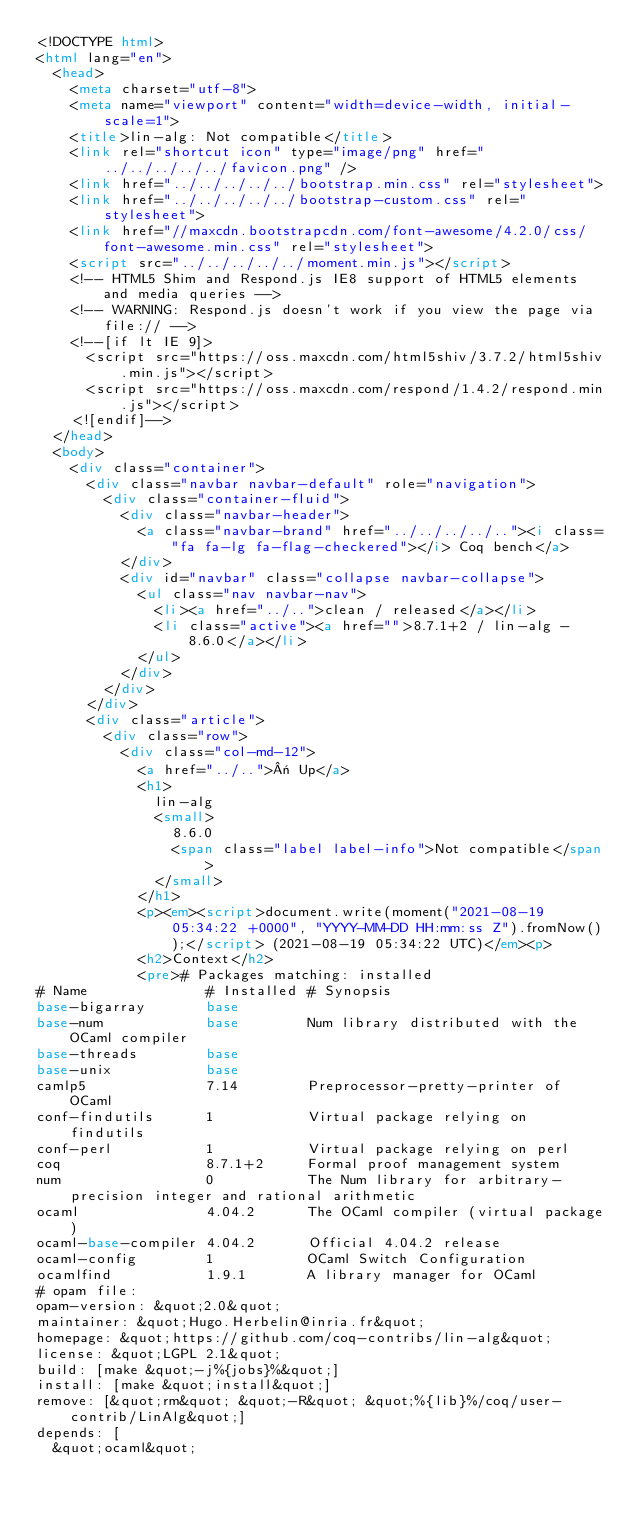Convert code to text. <code><loc_0><loc_0><loc_500><loc_500><_HTML_><!DOCTYPE html>
<html lang="en">
  <head>
    <meta charset="utf-8">
    <meta name="viewport" content="width=device-width, initial-scale=1">
    <title>lin-alg: Not compatible</title>
    <link rel="shortcut icon" type="image/png" href="../../../../../favicon.png" />
    <link href="../../../../../bootstrap.min.css" rel="stylesheet">
    <link href="../../../../../bootstrap-custom.css" rel="stylesheet">
    <link href="//maxcdn.bootstrapcdn.com/font-awesome/4.2.0/css/font-awesome.min.css" rel="stylesheet">
    <script src="../../../../../moment.min.js"></script>
    <!-- HTML5 Shim and Respond.js IE8 support of HTML5 elements and media queries -->
    <!-- WARNING: Respond.js doesn't work if you view the page via file:// -->
    <!--[if lt IE 9]>
      <script src="https://oss.maxcdn.com/html5shiv/3.7.2/html5shiv.min.js"></script>
      <script src="https://oss.maxcdn.com/respond/1.4.2/respond.min.js"></script>
    <![endif]-->
  </head>
  <body>
    <div class="container">
      <div class="navbar navbar-default" role="navigation">
        <div class="container-fluid">
          <div class="navbar-header">
            <a class="navbar-brand" href="../../../../.."><i class="fa fa-lg fa-flag-checkered"></i> Coq bench</a>
          </div>
          <div id="navbar" class="collapse navbar-collapse">
            <ul class="nav navbar-nav">
              <li><a href="../..">clean / released</a></li>
              <li class="active"><a href="">8.7.1+2 / lin-alg - 8.6.0</a></li>
            </ul>
          </div>
        </div>
      </div>
      <div class="article">
        <div class="row">
          <div class="col-md-12">
            <a href="../..">« Up</a>
            <h1>
              lin-alg
              <small>
                8.6.0
                <span class="label label-info">Not compatible</span>
              </small>
            </h1>
            <p><em><script>document.write(moment("2021-08-19 05:34:22 +0000", "YYYY-MM-DD HH:mm:ss Z").fromNow());</script> (2021-08-19 05:34:22 UTC)</em><p>
            <h2>Context</h2>
            <pre># Packages matching: installed
# Name              # Installed # Synopsis
base-bigarray       base
base-num            base        Num library distributed with the OCaml compiler
base-threads        base
base-unix           base
camlp5              7.14        Preprocessor-pretty-printer of OCaml
conf-findutils      1           Virtual package relying on findutils
conf-perl           1           Virtual package relying on perl
coq                 8.7.1+2     Formal proof management system
num                 0           The Num library for arbitrary-precision integer and rational arithmetic
ocaml               4.04.2      The OCaml compiler (virtual package)
ocaml-base-compiler 4.04.2      Official 4.04.2 release
ocaml-config        1           OCaml Switch Configuration
ocamlfind           1.9.1       A library manager for OCaml
# opam file:
opam-version: &quot;2.0&quot;
maintainer: &quot;Hugo.Herbelin@inria.fr&quot;
homepage: &quot;https://github.com/coq-contribs/lin-alg&quot;
license: &quot;LGPL 2.1&quot;
build: [make &quot;-j%{jobs}%&quot;]
install: [make &quot;install&quot;]
remove: [&quot;rm&quot; &quot;-R&quot; &quot;%{lib}%/coq/user-contrib/LinAlg&quot;]
depends: [
  &quot;ocaml&quot;</code> 